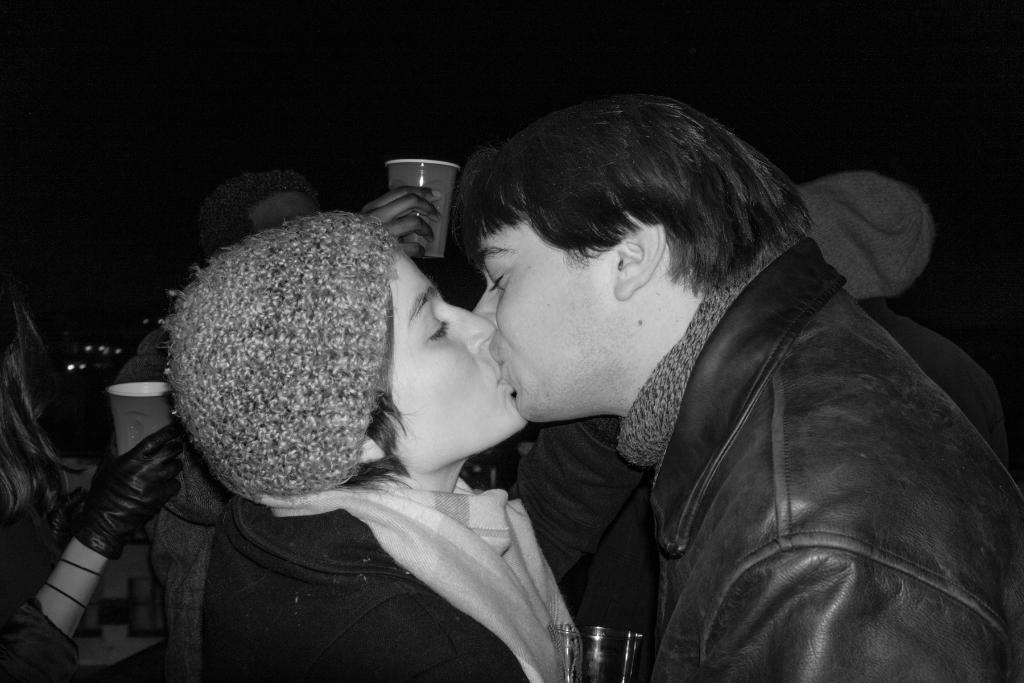Who are the two people in the image? There is a couple in the image. What are the couple doing in the image? The couple is kissing. What can be seen in the image besides the couple? There is a glass object in the image. What is the color of the background in the image? The background of the image is black. What is the name of the basin in the image? There is no basin present in the image. How fast is the couple running in the image? The couple is not running in the image; they are kissing. 